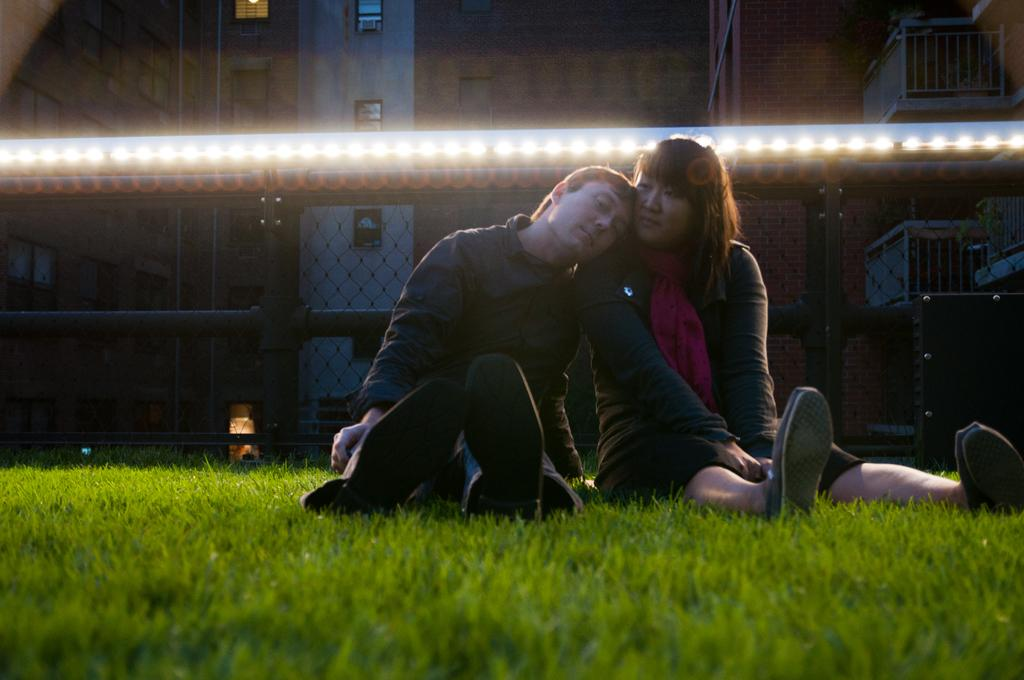How many people are in the image? There are two people in the image, a man and a woman. What are the man and woman doing in the image? Both the man and woman are sitting on the grass. the grass. What can be seen in the background of the image? There is a fence and buildings in the background of the image. Are there any artificial light sources visible in the image? Yes, lights are visible in the image. What type of credit card is the man holding in the image? There is no credit card visible in the image; the man is sitting on the grass with the woman. 